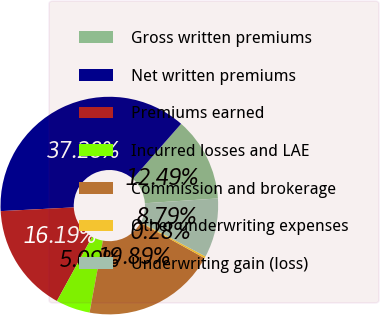Convert chart to OTSL. <chart><loc_0><loc_0><loc_500><loc_500><pie_chart><fcel>Gross written premiums<fcel>Net written premiums<fcel>Premiums earned<fcel>Incurred losses and LAE<fcel>Commission and brokerage<fcel>Other underwriting expenses<fcel>Underwriting gain (loss)<nl><fcel>12.49%<fcel>37.28%<fcel>16.19%<fcel>5.09%<fcel>19.89%<fcel>0.28%<fcel>8.79%<nl></chart> 